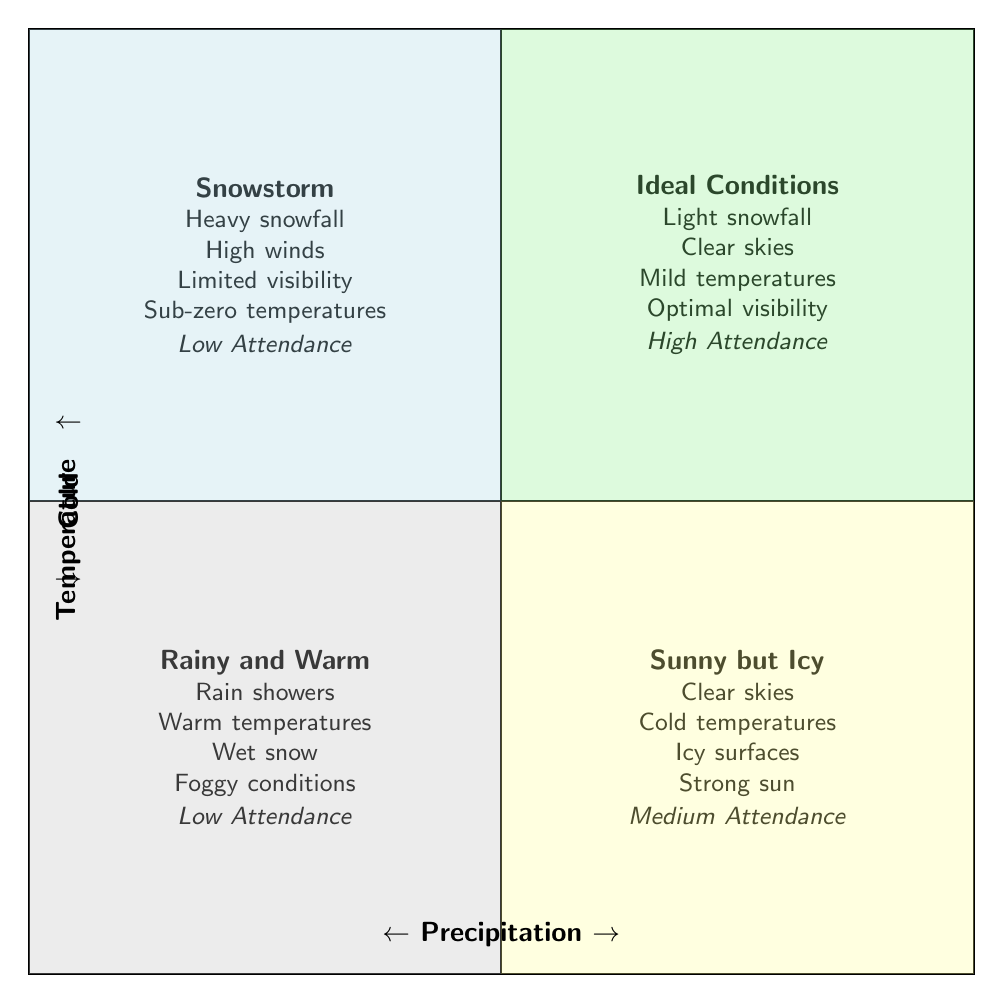What are the weather conditions in the "Ideal Conditions" quadrant? The "Ideal Conditions" quadrant lists the following weather conditions: Light snowfall, Clear skies, Mild temperatures, and Optimal visibility.
Answer: Light snowfall, Clear skies, Mild temperatures, Optimal visibility How many quadrants have "Low" visitor attendance? There are two quadrants indicated with "Low" visitor attendance: "Snowstorm" and "Rainy and Warm".
Answer: 2 What is the visitor attendance in the "Sunny but Icy" quadrant? The "Sunny but Icy" quadrant specifies that the visitor attendance is "Medium".
Answer: Medium Which quadrant has "Heavy snowfall" as a weather condition? The "Snowstorm" quadrant contains "Heavy snowfall" among the listed weather conditions.
Answer: Snowstorm In which quadrant do we find "High winds" as a weather condition? "High winds" are listed as a weather condition in the "Snowstorm" quadrant, indicating severe weather.
Answer: Snowstorm What type of visitor attendance is associated with "Clear skies" and "Warm temperatures"? The "Rainy and Warm" quadrant has these conditions and is associated with "Low" visitor attendance.
Answer: Low Which quadrant has the highest visitor attendance? The "Ideal Conditions" quadrant is noted for having the highest visitor attendance.
Answer: Ideal Conditions Which weather condition indicates "Limited visibility"? "Limited visibility" is listed as a weather condition under the "Snowstorm" quadrant.
Answer: Snowstorm 